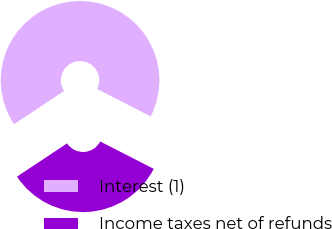<chart> <loc_0><loc_0><loc_500><loc_500><pie_chart><fcel>Interest (1)<fcel>Income taxes net of refunds<nl><fcel>66.84%<fcel>33.16%<nl></chart> 